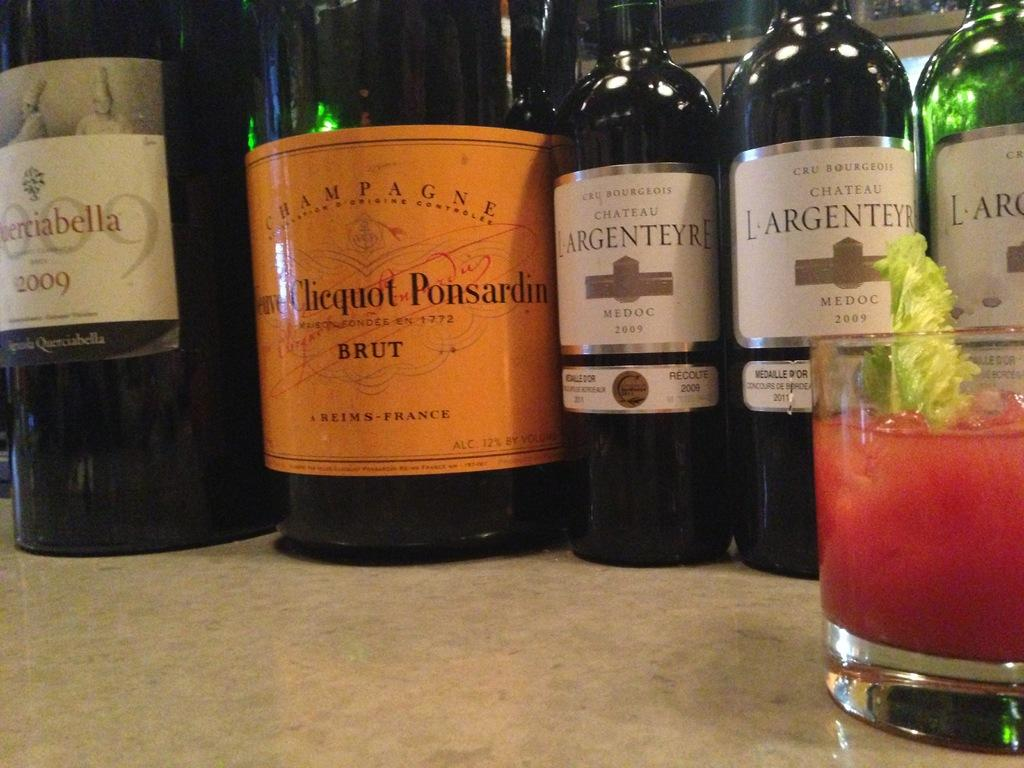Provide a one-sentence caption for the provided image. LARGENTEYRE wine bottles on top of a table. 